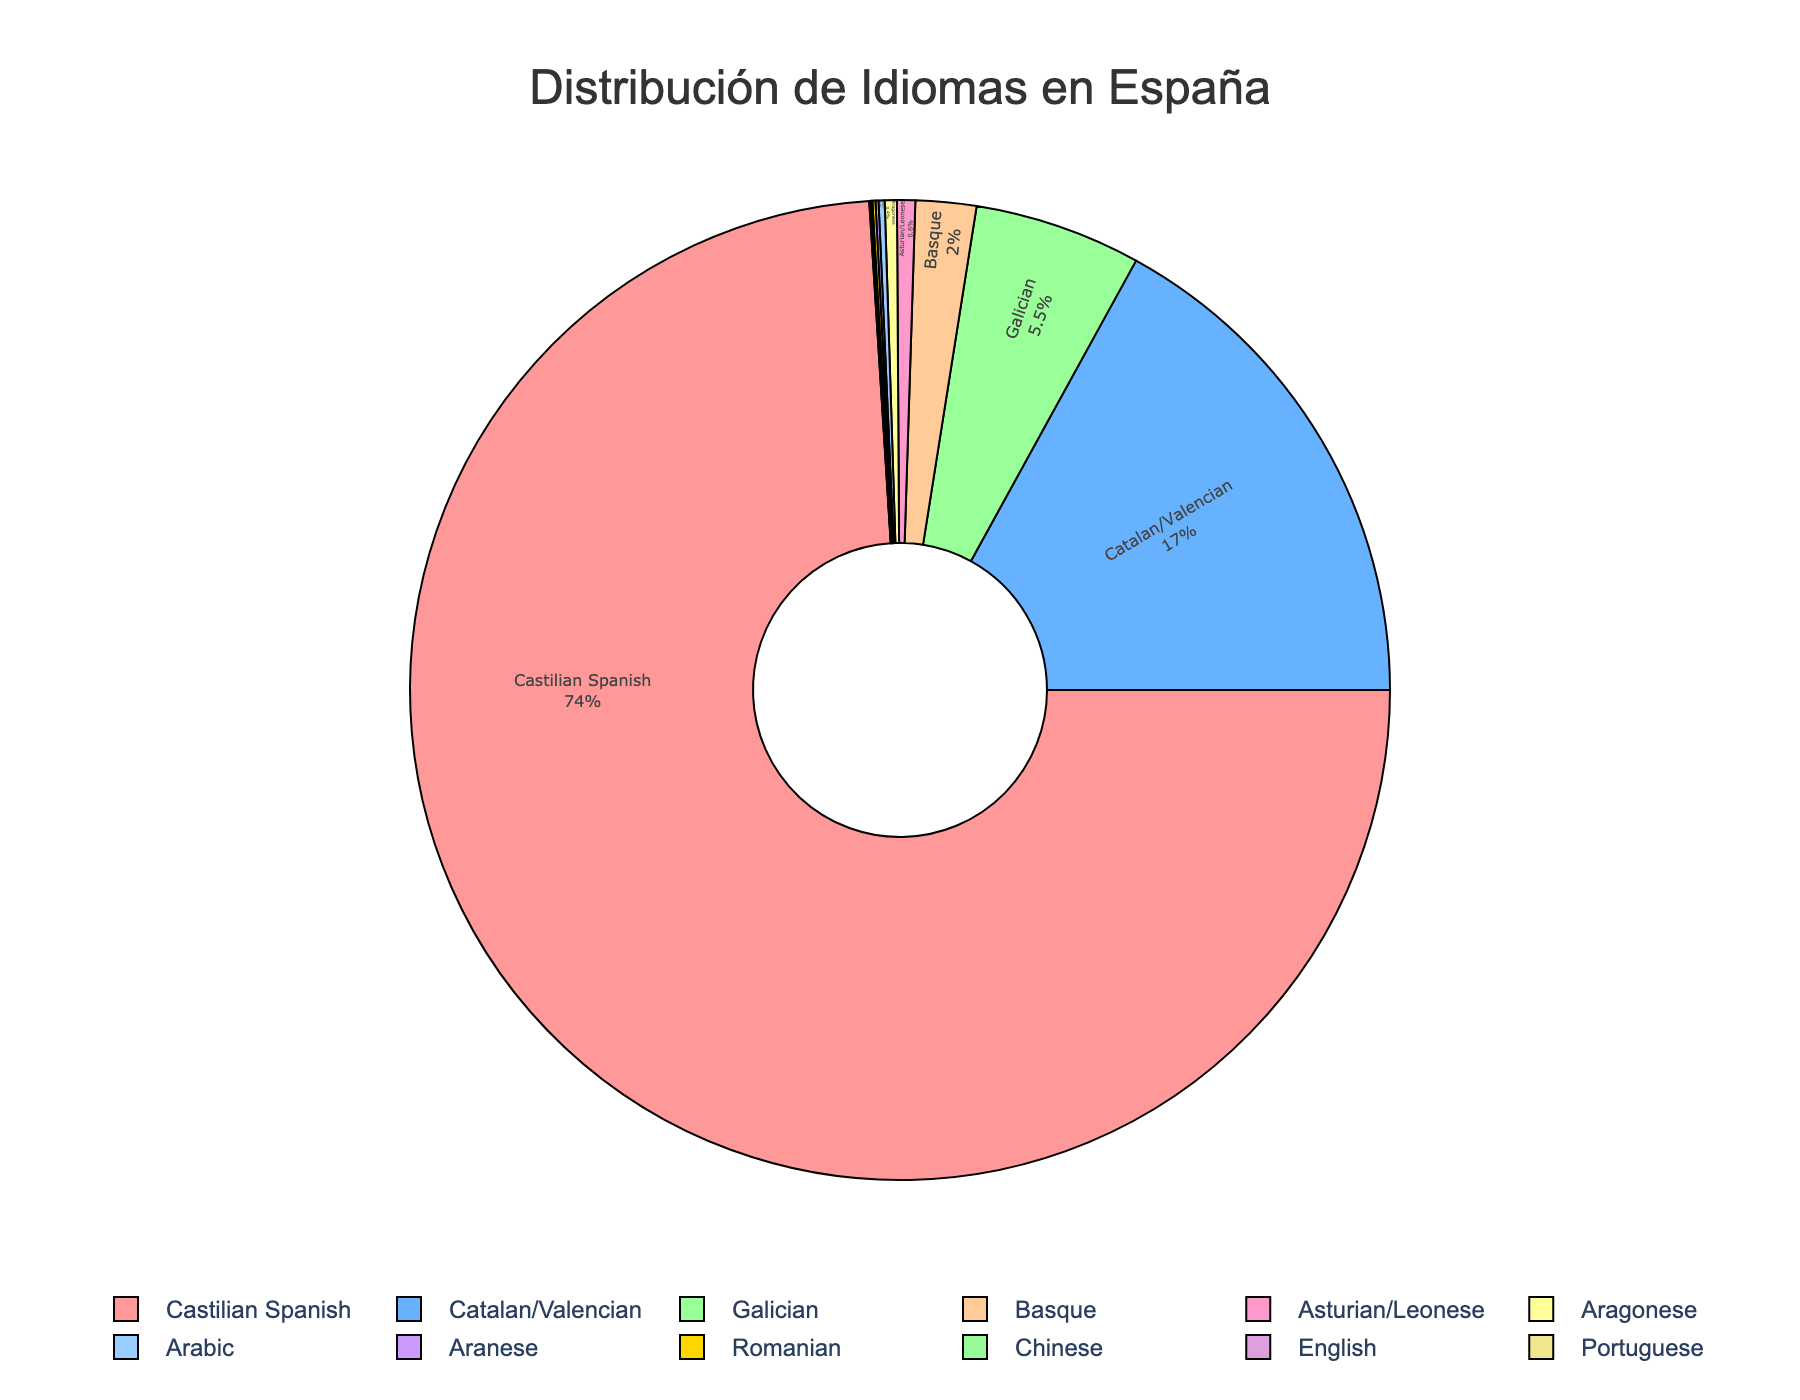What's the most widely spoken language in Spain? By looking at the pie chart, the largest segment represents Castilian Spanish with the highest percentage.
Answer: Castilian Spanish What percentage of languages spoken in Spain are regional dialects like Catalan, Galician, and Basque combined? Summing up the percentages of Catalan (17.0%), Galician (5.5%), and Basque (2.0%) gives us the total percentage of regional dialects. 17.0 + 5.5 + 2.0 = 24.5%
Answer: 24.5% Which language is spoken by a larger percentage of people, Catalan or Galician? By looking at the respective percentages, Catalan is spoken by 17.0% of people while Galician is spoken by 5.5%. Catalan has a larger percentage.
Answer: Catalan What is the combined percentage of languages spoken by less than 1% of the population each? Adding the percentages of Asturian/Leonese (0.6%), Aragonese (0.4%), Aranese (0.1%), Arabic (0.2%), Romanian (0.1%), Chinese (0.05%), English (0.03%), and Portuguese (0.02%) gives us the combined percentage. 0.6 + 0.4 + 0.1 + 0.2 + 0.1 + 0.05 + 0.03 + 0.02 = 1.5%
Answer: 1.5% Which language is represented by the light blue color in the chart? By identifying the light blue segment in the pie chart and referring to the legend, it corresponds to Catalan/Valencian.
Answer: Catalan/Valencian Is Castilian Spanish percentage larger or smaller than the combined percentage of Catalan/Valencian, Galician, and Basque? Adding up the percentages of Catalan/Valencian (17.0%), Galician (5.5%), and Basque (2.0%) gives 24.5%. Comparing it to Castilian Spanish (74.0%), Castilian Spanish percentage is larger.
Answer: Larger What is the smallest percentage language shown on the chart? By looking at the smallest segment in the pie chart and referring to the legend, Portuguese has the smallest percentage, 0.02%.
Answer: Portuguese How does the percentage of Asturian/Leonese compare to that of Aragonese? Asturian/Leonese has a percentage of 0.6% and Aragonese has 0.4%. Asturian/Leonese is 0.2% higher.
Answer: Asturian/Leonese is higher by 0.2% What is the total percentage represented by non-Spanish languages in the pie chart? Adding the percentages of Arabic (0.2%), Romanian (0.1%), Chinese (0.05%), English (0.03%), and Portuguese (0.02%) gives the total percentage of non-Spanish languages. 0.2 + 0.1 + 0.05 + 0.03 + 0.02 = 0.4%
Answer: 0.4% What is the difference between the percentage of Castilian Spanish and all other languages combined? First, sum the percentages of all other languages: 17 (Catalan) + 5.5 (Galician) + 2 (Basque) + 0.6 (Asturian) + 0.4 (Aragonese) + 0.1 (Aranese) + 0.2 (Arabic) + 0.1 (Romanian) + 0.05 (Chinese) + 0.03 (English) + 0.02 (Portuguese) = 25. For the difference, 74 (Castilian) - 25 = 49%.
Answer: 49% 